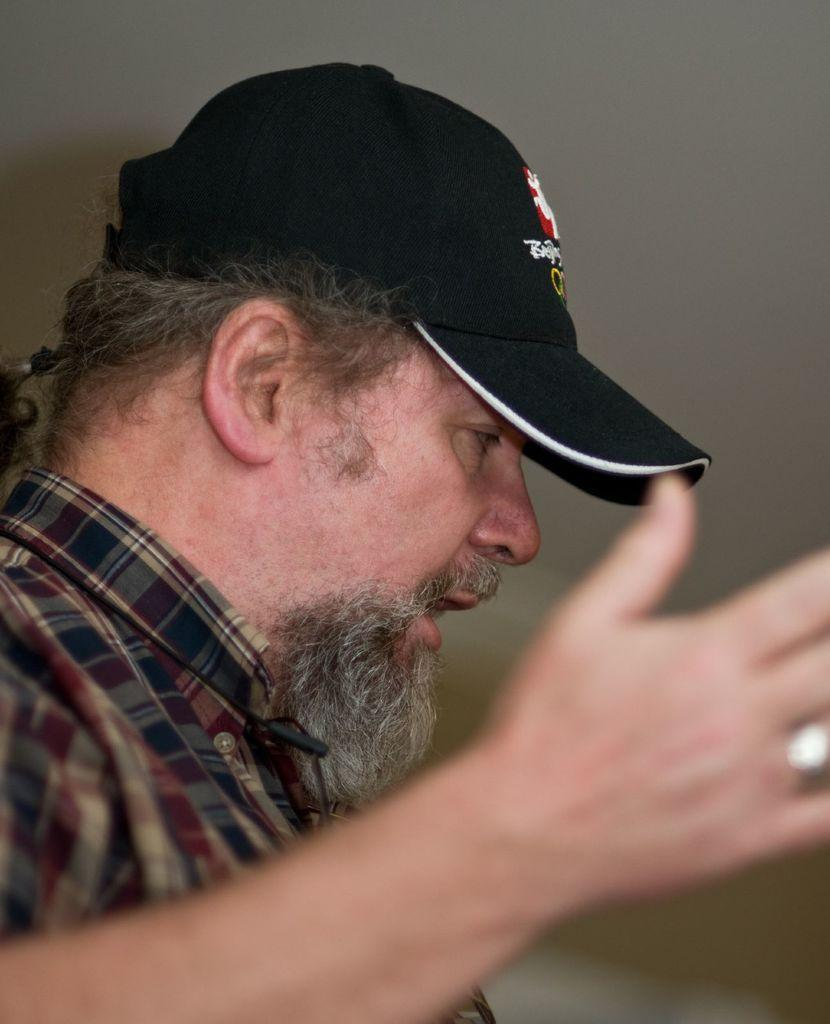Where was the image taken? The image was taken indoors. What can be seen in the background of the image? There is a wall in the background of the image. Can you describe the person on the left side of the image? There is a man on the left side of the image. What type of frame is around the man on the left side of the image? There is no frame around the man in the image; he is not framed or enclosed by any borders. 